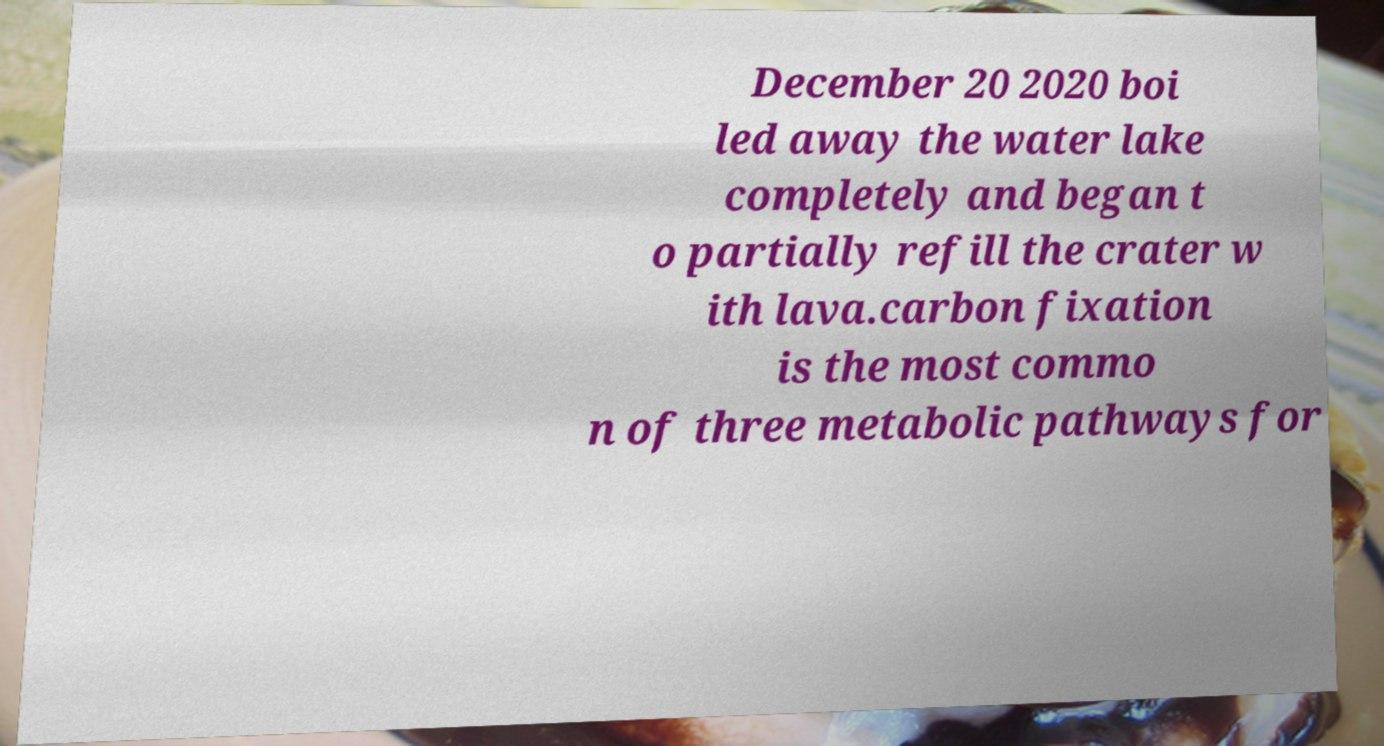Can you read and provide the text displayed in the image?This photo seems to have some interesting text. Can you extract and type it out for me? December 20 2020 boi led away the water lake completely and began t o partially refill the crater w ith lava.carbon fixation is the most commo n of three metabolic pathways for 